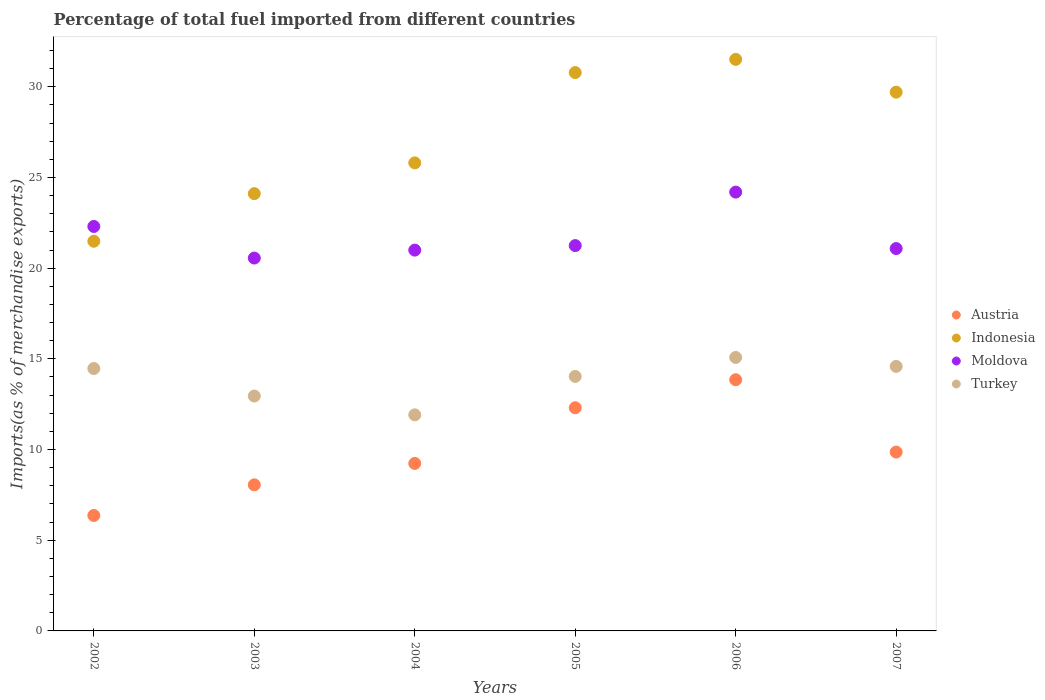How many different coloured dotlines are there?
Provide a short and direct response. 4. What is the percentage of imports to different countries in Turkey in 2006?
Ensure brevity in your answer.  15.08. Across all years, what is the maximum percentage of imports to different countries in Turkey?
Offer a very short reply. 15.08. Across all years, what is the minimum percentage of imports to different countries in Indonesia?
Ensure brevity in your answer.  21.48. In which year was the percentage of imports to different countries in Turkey maximum?
Offer a terse response. 2006. In which year was the percentage of imports to different countries in Indonesia minimum?
Your answer should be compact. 2002. What is the total percentage of imports to different countries in Moldova in the graph?
Your answer should be compact. 130.37. What is the difference between the percentage of imports to different countries in Indonesia in 2005 and that in 2006?
Provide a short and direct response. -0.73. What is the difference between the percentage of imports to different countries in Turkey in 2003 and the percentage of imports to different countries in Austria in 2005?
Offer a very short reply. 0.65. What is the average percentage of imports to different countries in Indonesia per year?
Make the answer very short. 27.23. In the year 2006, what is the difference between the percentage of imports to different countries in Turkey and percentage of imports to different countries in Indonesia?
Make the answer very short. -16.43. In how many years, is the percentage of imports to different countries in Moldova greater than 5 %?
Your answer should be compact. 6. What is the ratio of the percentage of imports to different countries in Turkey in 2002 to that in 2006?
Offer a very short reply. 0.96. Is the percentage of imports to different countries in Indonesia in 2003 less than that in 2007?
Your response must be concise. Yes. What is the difference between the highest and the second highest percentage of imports to different countries in Austria?
Keep it short and to the point. 1.55. What is the difference between the highest and the lowest percentage of imports to different countries in Austria?
Ensure brevity in your answer.  7.48. In how many years, is the percentage of imports to different countries in Moldova greater than the average percentage of imports to different countries in Moldova taken over all years?
Give a very brief answer. 2. Is the sum of the percentage of imports to different countries in Austria in 2004 and 2007 greater than the maximum percentage of imports to different countries in Turkey across all years?
Your answer should be compact. Yes. Is the percentage of imports to different countries in Austria strictly greater than the percentage of imports to different countries in Moldova over the years?
Provide a succinct answer. No. How many dotlines are there?
Make the answer very short. 4. What is the difference between two consecutive major ticks on the Y-axis?
Give a very brief answer. 5. Are the values on the major ticks of Y-axis written in scientific E-notation?
Ensure brevity in your answer.  No. Does the graph contain grids?
Offer a very short reply. No. How are the legend labels stacked?
Give a very brief answer. Vertical. What is the title of the graph?
Provide a short and direct response. Percentage of total fuel imported from different countries. Does "Trinidad and Tobago" appear as one of the legend labels in the graph?
Keep it short and to the point. No. What is the label or title of the Y-axis?
Provide a succinct answer. Imports(as % of merchandise exports). What is the Imports(as % of merchandise exports) in Austria in 2002?
Offer a very short reply. 6.37. What is the Imports(as % of merchandise exports) in Indonesia in 2002?
Your answer should be very brief. 21.48. What is the Imports(as % of merchandise exports) in Moldova in 2002?
Your answer should be compact. 22.3. What is the Imports(as % of merchandise exports) of Turkey in 2002?
Provide a short and direct response. 14.47. What is the Imports(as % of merchandise exports) of Austria in 2003?
Give a very brief answer. 8.05. What is the Imports(as % of merchandise exports) in Indonesia in 2003?
Offer a terse response. 24.11. What is the Imports(as % of merchandise exports) in Moldova in 2003?
Keep it short and to the point. 20.56. What is the Imports(as % of merchandise exports) in Turkey in 2003?
Keep it short and to the point. 12.95. What is the Imports(as % of merchandise exports) in Austria in 2004?
Provide a succinct answer. 9.24. What is the Imports(as % of merchandise exports) of Indonesia in 2004?
Your answer should be very brief. 25.8. What is the Imports(as % of merchandise exports) of Moldova in 2004?
Your answer should be very brief. 21. What is the Imports(as % of merchandise exports) of Turkey in 2004?
Give a very brief answer. 11.91. What is the Imports(as % of merchandise exports) of Austria in 2005?
Provide a succinct answer. 12.3. What is the Imports(as % of merchandise exports) in Indonesia in 2005?
Provide a short and direct response. 30.78. What is the Imports(as % of merchandise exports) of Moldova in 2005?
Offer a very short reply. 21.24. What is the Imports(as % of merchandise exports) of Turkey in 2005?
Provide a succinct answer. 14.03. What is the Imports(as % of merchandise exports) in Austria in 2006?
Your response must be concise. 13.85. What is the Imports(as % of merchandise exports) in Indonesia in 2006?
Give a very brief answer. 31.51. What is the Imports(as % of merchandise exports) in Moldova in 2006?
Make the answer very short. 24.19. What is the Imports(as % of merchandise exports) in Turkey in 2006?
Your answer should be compact. 15.08. What is the Imports(as % of merchandise exports) of Austria in 2007?
Provide a short and direct response. 9.86. What is the Imports(as % of merchandise exports) in Indonesia in 2007?
Offer a terse response. 29.7. What is the Imports(as % of merchandise exports) in Moldova in 2007?
Provide a short and direct response. 21.08. What is the Imports(as % of merchandise exports) of Turkey in 2007?
Ensure brevity in your answer.  14.58. Across all years, what is the maximum Imports(as % of merchandise exports) of Austria?
Your answer should be compact. 13.85. Across all years, what is the maximum Imports(as % of merchandise exports) in Indonesia?
Your answer should be compact. 31.51. Across all years, what is the maximum Imports(as % of merchandise exports) in Moldova?
Keep it short and to the point. 24.19. Across all years, what is the maximum Imports(as % of merchandise exports) of Turkey?
Offer a terse response. 15.08. Across all years, what is the minimum Imports(as % of merchandise exports) of Austria?
Make the answer very short. 6.37. Across all years, what is the minimum Imports(as % of merchandise exports) of Indonesia?
Give a very brief answer. 21.48. Across all years, what is the minimum Imports(as % of merchandise exports) in Moldova?
Make the answer very short. 20.56. Across all years, what is the minimum Imports(as % of merchandise exports) of Turkey?
Your response must be concise. 11.91. What is the total Imports(as % of merchandise exports) of Austria in the graph?
Offer a very short reply. 59.67. What is the total Imports(as % of merchandise exports) of Indonesia in the graph?
Your answer should be compact. 163.4. What is the total Imports(as % of merchandise exports) of Moldova in the graph?
Provide a succinct answer. 130.37. What is the total Imports(as % of merchandise exports) of Turkey in the graph?
Offer a terse response. 83.02. What is the difference between the Imports(as % of merchandise exports) of Austria in 2002 and that in 2003?
Provide a short and direct response. -1.69. What is the difference between the Imports(as % of merchandise exports) of Indonesia in 2002 and that in 2003?
Your response must be concise. -2.62. What is the difference between the Imports(as % of merchandise exports) in Moldova in 2002 and that in 2003?
Provide a succinct answer. 1.74. What is the difference between the Imports(as % of merchandise exports) of Turkey in 2002 and that in 2003?
Your answer should be very brief. 1.52. What is the difference between the Imports(as % of merchandise exports) of Austria in 2002 and that in 2004?
Your response must be concise. -2.87. What is the difference between the Imports(as % of merchandise exports) in Indonesia in 2002 and that in 2004?
Make the answer very short. -4.32. What is the difference between the Imports(as % of merchandise exports) of Moldova in 2002 and that in 2004?
Your answer should be very brief. 1.3. What is the difference between the Imports(as % of merchandise exports) of Turkey in 2002 and that in 2004?
Ensure brevity in your answer.  2.55. What is the difference between the Imports(as % of merchandise exports) in Austria in 2002 and that in 2005?
Offer a very short reply. -5.94. What is the difference between the Imports(as % of merchandise exports) of Indonesia in 2002 and that in 2005?
Your response must be concise. -9.3. What is the difference between the Imports(as % of merchandise exports) in Moldova in 2002 and that in 2005?
Give a very brief answer. 1.06. What is the difference between the Imports(as % of merchandise exports) in Turkey in 2002 and that in 2005?
Offer a terse response. 0.44. What is the difference between the Imports(as % of merchandise exports) in Austria in 2002 and that in 2006?
Ensure brevity in your answer.  -7.48. What is the difference between the Imports(as % of merchandise exports) in Indonesia in 2002 and that in 2006?
Keep it short and to the point. -10.03. What is the difference between the Imports(as % of merchandise exports) of Moldova in 2002 and that in 2006?
Your response must be concise. -1.89. What is the difference between the Imports(as % of merchandise exports) in Turkey in 2002 and that in 2006?
Keep it short and to the point. -0.61. What is the difference between the Imports(as % of merchandise exports) in Austria in 2002 and that in 2007?
Your response must be concise. -3.5. What is the difference between the Imports(as % of merchandise exports) of Indonesia in 2002 and that in 2007?
Offer a terse response. -8.22. What is the difference between the Imports(as % of merchandise exports) in Moldova in 2002 and that in 2007?
Your response must be concise. 1.22. What is the difference between the Imports(as % of merchandise exports) of Turkey in 2002 and that in 2007?
Your answer should be compact. -0.12. What is the difference between the Imports(as % of merchandise exports) in Austria in 2003 and that in 2004?
Provide a short and direct response. -1.18. What is the difference between the Imports(as % of merchandise exports) in Indonesia in 2003 and that in 2004?
Provide a short and direct response. -1.7. What is the difference between the Imports(as % of merchandise exports) in Moldova in 2003 and that in 2004?
Give a very brief answer. -0.44. What is the difference between the Imports(as % of merchandise exports) of Turkey in 2003 and that in 2004?
Make the answer very short. 1.04. What is the difference between the Imports(as % of merchandise exports) of Austria in 2003 and that in 2005?
Offer a terse response. -4.25. What is the difference between the Imports(as % of merchandise exports) of Indonesia in 2003 and that in 2005?
Offer a terse response. -6.67. What is the difference between the Imports(as % of merchandise exports) of Moldova in 2003 and that in 2005?
Provide a succinct answer. -0.69. What is the difference between the Imports(as % of merchandise exports) in Turkey in 2003 and that in 2005?
Offer a terse response. -1.08. What is the difference between the Imports(as % of merchandise exports) in Austria in 2003 and that in 2006?
Keep it short and to the point. -5.79. What is the difference between the Imports(as % of merchandise exports) of Indonesia in 2003 and that in 2006?
Give a very brief answer. -7.4. What is the difference between the Imports(as % of merchandise exports) of Moldova in 2003 and that in 2006?
Offer a terse response. -3.64. What is the difference between the Imports(as % of merchandise exports) in Turkey in 2003 and that in 2006?
Your answer should be compact. -2.13. What is the difference between the Imports(as % of merchandise exports) of Austria in 2003 and that in 2007?
Make the answer very short. -1.81. What is the difference between the Imports(as % of merchandise exports) in Indonesia in 2003 and that in 2007?
Keep it short and to the point. -5.59. What is the difference between the Imports(as % of merchandise exports) of Moldova in 2003 and that in 2007?
Offer a very short reply. -0.52. What is the difference between the Imports(as % of merchandise exports) in Turkey in 2003 and that in 2007?
Give a very brief answer. -1.63. What is the difference between the Imports(as % of merchandise exports) of Austria in 2004 and that in 2005?
Provide a succinct answer. -3.07. What is the difference between the Imports(as % of merchandise exports) in Indonesia in 2004 and that in 2005?
Your answer should be compact. -4.98. What is the difference between the Imports(as % of merchandise exports) of Moldova in 2004 and that in 2005?
Keep it short and to the point. -0.25. What is the difference between the Imports(as % of merchandise exports) in Turkey in 2004 and that in 2005?
Offer a very short reply. -2.12. What is the difference between the Imports(as % of merchandise exports) of Austria in 2004 and that in 2006?
Offer a terse response. -4.61. What is the difference between the Imports(as % of merchandise exports) of Indonesia in 2004 and that in 2006?
Your answer should be very brief. -5.71. What is the difference between the Imports(as % of merchandise exports) in Moldova in 2004 and that in 2006?
Provide a succinct answer. -3.2. What is the difference between the Imports(as % of merchandise exports) in Turkey in 2004 and that in 2006?
Ensure brevity in your answer.  -3.16. What is the difference between the Imports(as % of merchandise exports) in Austria in 2004 and that in 2007?
Your answer should be very brief. -0.63. What is the difference between the Imports(as % of merchandise exports) of Indonesia in 2004 and that in 2007?
Your answer should be very brief. -3.9. What is the difference between the Imports(as % of merchandise exports) of Moldova in 2004 and that in 2007?
Provide a short and direct response. -0.09. What is the difference between the Imports(as % of merchandise exports) of Turkey in 2004 and that in 2007?
Your answer should be compact. -2.67. What is the difference between the Imports(as % of merchandise exports) in Austria in 2005 and that in 2006?
Offer a terse response. -1.55. What is the difference between the Imports(as % of merchandise exports) of Indonesia in 2005 and that in 2006?
Offer a very short reply. -0.73. What is the difference between the Imports(as % of merchandise exports) in Moldova in 2005 and that in 2006?
Your response must be concise. -2.95. What is the difference between the Imports(as % of merchandise exports) of Turkey in 2005 and that in 2006?
Offer a terse response. -1.05. What is the difference between the Imports(as % of merchandise exports) in Austria in 2005 and that in 2007?
Keep it short and to the point. 2.44. What is the difference between the Imports(as % of merchandise exports) of Indonesia in 2005 and that in 2007?
Give a very brief answer. 1.08. What is the difference between the Imports(as % of merchandise exports) of Moldova in 2005 and that in 2007?
Your answer should be compact. 0.16. What is the difference between the Imports(as % of merchandise exports) of Turkey in 2005 and that in 2007?
Make the answer very short. -0.55. What is the difference between the Imports(as % of merchandise exports) in Austria in 2006 and that in 2007?
Offer a very short reply. 3.99. What is the difference between the Imports(as % of merchandise exports) of Indonesia in 2006 and that in 2007?
Offer a very short reply. 1.81. What is the difference between the Imports(as % of merchandise exports) of Moldova in 2006 and that in 2007?
Ensure brevity in your answer.  3.11. What is the difference between the Imports(as % of merchandise exports) in Turkey in 2006 and that in 2007?
Make the answer very short. 0.49. What is the difference between the Imports(as % of merchandise exports) of Austria in 2002 and the Imports(as % of merchandise exports) of Indonesia in 2003?
Make the answer very short. -17.74. What is the difference between the Imports(as % of merchandise exports) in Austria in 2002 and the Imports(as % of merchandise exports) in Moldova in 2003?
Your answer should be compact. -14.19. What is the difference between the Imports(as % of merchandise exports) of Austria in 2002 and the Imports(as % of merchandise exports) of Turkey in 2003?
Give a very brief answer. -6.59. What is the difference between the Imports(as % of merchandise exports) of Indonesia in 2002 and the Imports(as % of merchandise exports) of Moldova in 2003?
Provide a short and direct response. 0.93. What is the difference between the Imports(as % of merchandise exports) in Indonesia in 2002 and the Imports(as % of merchandise exports) in Turkey in 2003?
Your response must be concise. 8.53. What is the difference between the Imports(as % of merchandise exports) of Moldova in 2002 and the Imports(as % of merchandise exports) of Turkey in 2003?
Your response must be concise. 9.35. What is the difference between the Imports(as % of merchandise exports) of Austria in 2002 and the Imports(as % of merchandise exports) of Indonesia in 2004?
Provide a succinct answer. -19.44. What is the difference between the Imports(as % of merchandise exports) of Austria in 2002 and the Imports(as % of merchandise exports) of Moldova in 2004?
Make the answer very short. -14.63. What is the difference between the Imports(as % of merchandise exports) in Austria in 2002 and the Imports(as % of merchandise exports) in Turkey in 2004?
Offer a terse response. -5.55. What is the difference between the Imports(as % of merchandise exports) of Indonesia in 2002 and the Imports(as % of merchandise exports) of Moldova in 2004?
Offer a terse response. 0.49. What is the difference between the Imports(as % of merchandise exports) of Indonesia in 2002 and the Imports(as % of merchandise exports) of Turkey in 2004?
Your answer should be compact. 9.57. What is the difference between the Imports(as % of merchandise exports) of Moldova in 2002 and the Imports(as % of merchandise exports) of Turkey in 2004?
Provide a succinct answer. 10.39. What is the difference between the Imports(as % of merchandise exports) of Austria in 2002 and the Imports(as % of merchandise exports) of Indonesia in 2005?
Offer a terse response. -24.42. What is the difference between the Imports(as % of merchandise exports) of Austria in 2002 and the Imports(as % of merchandise exports) of Moldova in 2005?
Provide a succinct answer. -14.88. What is the difference between the Imports(as % of merchandise exports) of Austria in 2002 and the Imports(as % of merchandise exports) of Turkey in 2005?
Your response must be concise. -7.67. What is the difference between the Imports(as % of merchandise exports) of Indonesia in 2002 and the Imports(as % of merchandise exports) of Moldova in 2005?
Your answer should be compact. 0.24. What is the difference between the Imports(as % of merchandise exports) in Indonesia in 2002 and the Imports(as % of merchandise exports) in Turkey in 2005?
Your response must be concise. 7.45. What is the difference between the Imports(as % of merchandise exports) of Moldova in 2002 and the Imports(as % of merchandise exports) of Turkey in 2005?
Give a very brief answer. 8.27. What is the difference between the Imports(as % of merchandise exports) in Austria in 2002 and the Imports(as % of merchandise exports) in Indonesia in 2006?
Provide a succinct answer. -25.15. What is the difference between the Imports(as % of merchandise exports) of Austria in 2002 and the Imports(as % of merchandise exports) of Moldova in 2006?
Your answer should be very brief. -17.83. What is the difference between the Imports(as % of merchandise exports) in Austria in 2002 and the Imports(as % of merchandise exports) in Turkey in 2006?
Provide a short and direct response. -8.71. What is the difference between the Imports(as % of merchandise exports) in Indonesia in 2002 and the Imports(as % of merchandise exports) in Moldova in 2006?
Your response must be concise. -2.71. What is the difference between the Imports(as % of merchandise exports) in Indonesia in 2002 and the Imports(as % of merchandise exports) in Turkey in 2006?
Your response must be concise. 6.41. What is the difference between the Imports(as % of merchandise exports) in Moldova in 2002 and the Imports(as % of merchandise exports) in Turkey in 2006?
Provide a succinct answer. 7.22. What is the difference between the Imports(as % of merchandise exports) of Austria in 2002 and the Imports(as % of merchandise exports) of Indonesia in 2007?
Ensure brevity in your answer.  -23.34. What is the difference between the Imports(as % of merchandise exports) in Austria in 2002 and the Imports(as % of merchandise exports) in Moldova in 2007?
Your answer should be compact. -14.72. What is the difference between the Imports(as % of merchandise exports) of Austria in 2002 and the Imports(as % of merchandise exports) of Turkey in 2007?
Offer a terse response. -8.22. What is the difference between the Imports(as % of merchandise exports) of Indonesia in 2002 and the Imports(as % of merchandise exports) of Moldova in 2007?
Give a very brief answer. 0.4. What is the difference between the Imports(as % of merchandise exports) in Indonesia in 2002 and the Imports(as % of merchandise exports) in Turkey in 2007?
Offer a very short reply. 6.9. What is the difference between the Imports(as % of merchandise exports) in Moldova in 2002 and the Imports(as % of merchandise exports) in Turkey in 2007?
Your response must be concise. 7.72. What is the difference between the Imports(as % of merchandise exports) of Austria in 2003 and the Imports(as % of merchandise exports) of Indonesia in 2004?
Provide a short and direct response. -17.75. What is the difference between the Imports(as % of merchandise exports) in Austria in 2003 and the Imports(as % of merchandise exports) in Moldova in 2004?
Make the answer very short. -12.94. What is the difference between the Imports(as % of merchandise exports) of Austria in 2003 and the Imports(as % of merchandise exports) of Turkey in 2004?
Provide a short and direct response. -3.86. What is the difference between the Imports(as % of merchandise exports) of Indonesia in 2003 and the Imports(as % of merchandise exports) of Moldova in 2004?
Your answer should be very brief. 3.11. What is the difference between the Imports(as % of merchandise exports) of Indonesia in 2003 and the Imports(as % of merchandise exports) of Turkey in 2004?
Provide a succinct answer. 12.2. What is the difference between the Imports(as % of merchandise exports) of Moldova in 2003 and the Imports(as % of merchandise exports) of Turkey in 2004?
Make the answer very short. 8.64. What is the difference between the Imports(as % of merchandise exports) of Austria in 2003 and the Imports(as % of merchandise exports) of Indonesia in 2005?
Your answer should be compact. -22.73. What is the difference between the Imports(as % of merchandise exports) in Austria in 2003 and the Imports(as % of merchandise exports) in Moldova in 2005?
Offer a very short reply. -13.19. What is the difference between the Imports(as % of merchandise exports) of Austria in 2003 and the Imports(as % of merchandise exports) of Turkey in 2005?
Offer a terse response. -5.98. What is the difference between the Imports(as % of merchandise exports) in Indonesia in 2003 and the Imports(as % of merchandise exports) in Moldova in 2005?
Ensure brevity in your answer.  2.86. What is the difference between the Imports(as % of merchandise exports) of Indonesia in 2003 and the Imports(as % of merchandise exports) of Turkey in 2005?
Give a very brief answer. 10.08. What is the difference between the Imports(as % of merchandise exports) of Moldova in 2003 and the Imports(as % of merchandise exports) of Turkey in 2005?
Keep it short and to the point. 6.53. What is the difference between the Imports(as % of merchandise exports) of Austria in 2003 and the Imports(as % of merchandise exports) of Indonesia in 2006?
Your response must be concise. -23.46. What is the difference between the Imports(as % of merchandise exports) of Austria in 2003 and the Imports(as % of merchandise exports) of Moldova in 2006?
Offer a very short reply. -16.14. What is the difference between the Imports(as % of merchandise exports) of Austria in 2003 and the Imports(as % of merchandise exports) of Turkey in 2006?
Offer a very short reply. -7.02. What is the difference between the Imports(as % of merchandise exports) in Indonesia in 2003 and the Imports(as % of merchandise exports) in Moldova in 2006?
Give a very brief answer. -0.08. What is the difference between the Imports(as % of merchandise exports) in Indonesia in 2003 and the Imports(as % of merchandise exports) in Turkey in 2006?
Your answer should be very brief. 9.03. What is the difference between the Imports(as % of merchandise exports) in Moldova in 2003 and the Imports(as % of merchandise exports) in Turkey in 2006?
Ensure brevity in your answer.  5.48. What is the difference between the Imports(as % of merchandise exports) of Austria in 2003 and the Imports(as % of merchandise exports) of Indonesia in 2007?
Give a very brief answer. -21.65. What is the difference between the Imports(as % of merchandise exports) of Austria in 2003 and the Imports(as % of merchandise exports) of Moldova in 2007?
Ensure brevity in your answer.  -13.03. What is the difference between the Imports(as % of merchandise exports) in Austria in 2003 and the Imports(as % of merchandise exports) in Turkey in 2007?
Ensure brevity in your answer.  -6.53. What is the difference between the Imports(as % of merchandise exports) of Indonesia in 2003 and the Imports(as % of merchandise exports) of Moldova in 2007?
Your response must be concise. 3.03. What is the difference between the Imports(as % of merchandise exports) of Indonesia in 2003 and the Imports(as % of merchandise exports) of Turkey in 2007?
Provide a short and direct response. 9.53. What is the difference between the Imports(as % of merchandise exports) of Moldova in 2003 and the Imports(as % of merchandise exports) of Turkey in 2007?
Make the answer very short. 5.97. What is the difference between the Imports(as % of merchandise exports) of Austria in 2004 and the Imports(as % of merchandise exports) of Indonesia in 2005?
Ensure brevity in your answer.  -21.55. What is the difference between the Imports(as % of merchandise exports) in Austria in 2004 and the Imports(as % of merchandise exports) in Moldova in 2005?
Provide a short and direct response. -12.01. What is the difference between the Imports(as % of merchandise exports) of Austria in 2004 and the Imports(as % of merchandise exports) of Turkey in 2005?
Keep it short and to the point. -4.8. What is the difference between the Imports(as % of merchandise exports) of Indonesia in 2004 and the Imports(as % of merchandise exports) of Moldova in 2005?
Provide a succinct answer. 4.56. What is the difference between the Imports(as % of merchandise exports) of Indonesia in 2004 and the Imports(as % of merchandise exports) of Turkey in 2005?
Provide a short and direct response. 11.77. What is the difference between the Imports(as % of merchandise exports) in Moldova in 2004 and the Imports(as % of merchandise exports) in Turkey in 2005?
Provide a short and direct response. 6.96. What is the difference between the Imports(as % of merchandise exports) in Austria in 2004 and the Imports(as % of merchandise exports) in Indonesia in 2006?
Provide a short and direct response. -22.28. What is the difference between the Imports(as % of merchandise exports) of Austria in 2004 and the Imports(as % of merchandise exports) of Moldova in 2006?
Offer a very short reply. -14.96. What is the difference between the Imports(as % of merchandise exports) of Austria in 2004 and the Imports(as % of merchandise exports) of Turkey in 2006?
Make the answer very short. -5.84. What is the difference between the Imports(as % of merchandise exports) in Indonesia in 2004 and the Imports(as % of merchandise exports) in Moldova in 2006?
Offer a very short reply. 1.61. What is the difference between the Imports(as % of merchandise exports) of Indonesia in 2004 and the Imports(as % of merchandise exports) of Turkey in 2006?
Your answer should be compact. 10.73. What is the difference between the Imports(as % of merchandise exports) in Moldova in 2004 and the Imports(as % of merchandise exports) in Turkey in 2006?
Offer a very short reply. 5.92. What is the difference between the Imports(as % of merchandise exports) of Austria in 2004 and the Imports(as % of merchandise exports) of Indonesia in 2007?
Give a very brief answer. -20.47. What is the difference between the Imports(as % of merchandise exports) of Austria in 2004 and the Imports(as % of merchandise exports) of Moldova in 2007?
Give a very brief answer. -11.85. What is the difference between the Imports(as % of merchandise exports) of Austria in 2004 and the Imports(as % of merchandise exports) of Turkey in 2007?
Offer a terse response. -5.35. What is the difference between the Imports(as % of merchandise exports) of Indonesia in 2004 and the Imports(as % of merchandise exports) of Moldova in 2007?
Ensure brevity in your answer.  4.72. What is the difference between the Imports(as % of merchandise exports) in Indonesia in 2004 and the Imports(as % of merchandise exports) in Turkey in 2007?
Offer a terse response. 11.22. What is the difference between the Imports(as % of merchandise exports) in Moldova in 2004 and the Imports(as % of merchandise exports) in Turkey in 2007?
Ensure brevity in your answer.  6.41. What is the difference between the Imports(as % of merchandise exports) in Austria in 2005 and the Imports(as % of merchandise exports) in Indonesia in 2006?
Your answer should be compact. -19.21. What is the difference between the Imports(as % of merchandise exports) in Austria in 2005 and the Imports(as % of merchandise exports) in Moldova in 2006?
Your answer should be very brief. -11.89. What is the difference between the Imports(as % of merchandise exports) of Austria in 2005 and the Imports(as % of merchandise exports) of Turkey in 2006?
Your answer should be compact. -2.77. What is the difference between the Imports(as % of merchandise exports) in Indonesia in 2005 and the Imports(as % of merchandise exports) in Moldova in 2006?
Make the answer very short. 6.59. What is the difference between the Imports(as % of merchandise exports) of Indonesia in 2005 and the Imports(as % of merchandise exports) of Turkey in 2006?
Your response must be concise. 15.71. What is the difference between the Imports(as % of merchandise exports) in Moldova in 2005 and the Imports(as % of merchandise exports) in Turkey in 2006?
Your answer should be very brief. 6.17. What is the difference between the Imports(as % of merchandise exports) of Austria in 2005 and the Imports(as % of merchandise exports) of Indonesia in 2007?
Your answer should be very brief. -17.4. What is the difference between the Imports(as % of merchandise exports) of Austria in 2005 and the Imports(as % of merchandise exports) of Moldova in 2007?
Your response must be concise. -8.78. What is the difference between the Imports(as % of merchandise exports) in Austria in 2005 and the Imports(as % of merchandise exports) in Turkey in 2007?
Offer a terse response. -2.28. What is the difference between the Imports(as % of merchandise exports) of Indonesia in 2005 and the Imports(as % of merchandise exports) of Moldova in 2007?
Your answer should be compact. 9.7. What is the difference between the Imports(as % of merchandise exports) in Indonesia in 2005 and the Imports(as % of merchandise exports) in Turkey in 2007?
Ensure brevity in your answer.  16.2. What is the difference between the Imports(as % of merchandise exports) of Moldova in 2005 and the Imports(as % of merchandise exports) of Turkey in 2007?
Offer a terse response. 6.66. What is the difference between the Imports(as % of merchandise exports) of Austria in 2006 and the Imports(as % of merchandise exports) of Indonesia in 2007?
Offer a terse response. -15.86. What is the difference between the Imports(as % of merchandise exports) in Austria in 2006 and the Imports(as % of merchandise exports) in Moldova in 2007?
Give a very brief answer. -7.23. What is the difference between the Imports(as % of merchandise exports) of Austria in 2006 and the Imports(as % of merchandise exports) of Turkey in 2007?
Ensure brevity in your answer.  -0.74. What is the difference between the Imports(as % of merchandise exports) in Indonesia in 2006 and the Imports(as % of merchandise exports) in Moldova in 2007?
Your answer should be compact. 10.43. What is the difference between the Imports(as % of merchandise exports) of Indonesia in 2006 and the Imports(as % of merchandise exports) of Turkey in 2007?
Offer a terse response. 16.93. What is the difference between the Imports(as % of merchandise exports) in Moldova in 2006 and the Imports(as % of merchandise exports) in Turkey in 2007?
Your answer should be compact. 9.61. What is the average Imports(as % of merchandise exports) of Austria per year?
Your response must be concise. 9.94. What is the average Imports(as % of merchandise exports) of Indonesia per year?
Your response must be concise. 27.23. What is the average Imports(as % of merchandise exports) of Moldova per year?
Your answer should be very brief. 21.73. What is the average Imports(as % of merchandise exports) in Turkey per year?
Make the answer very short. 13.84. In the year 2002, what is the difference between the Imports(as % of merchandise exports) in Austria and Imports(as % of merchandise exports) in Indonesia?
Your answer should be compact. -15.12. In the year 2002, what is the difference between the Imports(as % of merchandise exports) in Austria and Imports(as % of merchandise exports) in Moldova?
Your answer should be very brief. -15.94. In the year 2002, what is the difference between the Imports(as % of merchandise exports) in Austria and Imports(as % of merchandise exports) in Turkey?
Give a very brief answer. -8.1. In the year 2002, what is the difference between the Imports(as % of merchandise exports) of Indonesia and Imports(as % of merchandise exports) of Moldova?
Offer a terse response. -0.82. In the year 2002, what is the difference between the Imports(as % of merchandise exports) in Indonesia and Imports(as % of merchandise exports) in Turkey?
Make the answer very short. 7.02. In the year 2002, what is the difference between the Imports(as % of merchandise exports) in Moldova and Imports(as % of merchandise exports) in Turkey?
Make the answer very short. 7.83. In the year 2003, what is the difference between the Imports(as % of merchandise exports) in Austria and Imports(as % of merchandise exports) in Indonesia?
Provide a succinct answer. -16.05. In the year 2003, what is the difference between the Imports(as % of merchandise exports) of Austria and Imports(as % of merchandise exports) of Moldova?
Make the answer very short. -12.5. In the year 2003, what is the difference between the Imports(as % of merchandise exports) in Austria and Imports(as % of merchandise exports) in Turkey?
Your answer should be compact. -4.9. In the year 2003, what is the difference between the Imports(as % of merchandise exports) in Indonesia and Imports(as % of merchandise exports) in Moldova?
Give a very brief answer. 3.55. In the year 2003, what is the difference between the Imports(as % of merchandise exports) in Indonesia and Imports(as % of merchandise exports) in Turkey?
Make the answer very short. 11.16. In the year 2003, what is the difference between the Imports(as % of merchandise exports) of Moldova and Imports(as % of merchandise exports) of Turkey?
Your answer should be very brief. 7.61. In the year 2004, what is the difference between the Imports(as % of merchandise exports) of Austria and Imports(as % of merchandise exports) of Indonesia?
Your answer should be compact. -16.57. In the year 2004, what is the difference between the Imports(as % of merchandise exports) in Austria and Imports(as % of merchandise exports) in Moldova?
Give a very brief answer. -11.76. In the year 2004, what is the difference between the Imports(as % of merchandise exports) of Austria and Imports(as % of merchandise exports) of Turkey?
Ensure brevity in your answer.  -2.68. In the year 2004, what is the difference between the Imports(as % of merchandise exports) of Indonesia and Imports(as % of merchandise exports) of Moldova?
Make the answer very short. 4.81. In the year 2004, what is the difference between the Imports(as % of merchandise exports) in Indonesia and Imports(as % of merchandise exports) in Turkey?
Your answer should be compact. 13.89. In the year 2004, what is the difference between the Imports(as % of merchandise exports) in Moldova and Imports(as % of merchandise exports) in Turkey?
Offer a terse response. 9.08. In the year 2005, what is the difference between the Imports(as % of merchandise exports) in Austria and Imports(as % of merchandise exports) in Indonesia?
Provide a succinct answer. -18.48. In the year 2005, what is the difference between the Imports(as % of merchandise exports) in Austria and Imports(as % of merchandise exports) in Moldova?
Ensure brevity in your answer.  -8.94. In the year 2005, what is the difference between the Imports(as % of merchandise exports) in Austria and Imports(as % of merchandise exports) in Turkey?
Ensure brevity in your answer.  -1.73. In the year 2005, what is the difference between the Imports(as % of merchandise exports) of Indonesia and Imports(as % of merchandise exports) of Moldova?
Your response must be concise. 9.54. In the year 2005, what is the difference between the Imports(as % of merchandise exports) of Indonesia and Imports(as % of merchandise exports) of Turkey?
Offer a terse response. 16.75. In the year 2005, what is the difference between the Imports(as % of merchandise exports) of Moldova and Imports(as % of merchandise exports) of Turkey?
Your answer should be compact. 7.21. In the year 2006, what is the difference between the Imports(as % of merchandise exports) in Austria and Imports(as % of merchandise exports) in Indonesia?
Make the answer very short. -17.66. In the year 2006, what is the difference between the Imports(as % of merchandise exports) in Austria and Imports(as % of merchandise exports) in Moldova?
Provide a succinct answer. -10.35. In the year 2006, what is the difference between the Imports(as % of merchandise exports) in Austria and Imports(as % of merchandise exports) in Turkey?
Offer a very short reply. -1.23. In the year 2006, what is the difference between the Imports(as % of merchandise exports) of Indonesia and Imports(as % of merchandise exports) of Moldova?
Ensure brevity in your answer.  7.32. In the year 2006, what is the difference between the Imports(as % of merchandise exports) in Indonesia and Imports(as % of merchandise exports) in Turkey?
Keep it short and to the point. 16.43. In the year 2006, what is the difference between the Imports(as % of merchandise exports) of Moldova and Imports(as % of merchandise exports) of Turkey?
Your answer should be very brief. 9.12. In the year 2007, what is the difference between the Imports(as % of merchandise exports) of Austria and Imports(as % of merchandise exports) of Indonesia?
Make the answer very short. -19.84. In the year 2007, what is the difference between the Imports(as % of merchandise exports) in Austria and Imports(as % of merchandise exports) in Moldova?
Your answer should be very brief. -11.22. In the year 2007, what is the difference between the Imports(as % of merchandise exports) of Austria and Imports(as % of merchandise exports) of Turkey?
Your answer should be very brief. -4.72. In the year 2007, what is the difference between the Imports(as % of merchandise exports) of Indonesia and Imports(as % of merchandise exports) of Moldova?
Your answer should be very brief. 8.62. In the year 2007, what is the difference between the Imports(as % of merchandise exports) of Indonesia and Imports(as % of merchandise exports) of Turkey?
Make the answer very short. 15.12. In the year 2007, what is the difference between the Imports(as % of merchandise exports) of Moldova and Imports(as % of merchandise exports) of Turkey?
Provide a succinct answer. 6.5. What is the ratio of the Imports(as % of merchandise exports) of Austria in 2002 to that in 2003?
Your answer should be compact. 0.79. What is the ratio of the Imports(as % of merchandise exports) in Indonesia in 2002 to that in 2003?
Provide a short and direct response. 0.89. What is the ratio of the Imports(as % of merchandise exports) of Moldova in 2002 to that in 2003?
Make the answer very short. 1.08. What is the ratio of the Imports(as % of merchandise exports) in Turkey in 2002 to that in 2003?
Provide a succinct answer. 1.12. What is the ratio of the Imports(as % of merchandise exports) in Austria in 2002 to that in 2004?
Your answer should be compact. 0.69. What is the ratio of the Imports(as % of merchandise exports) of Indonesia in 2002 to that in 2004?
Keep it short and to the point. 0.83. What is the ratio of the Imports(as % of merchandise exports) of Moldova in 2002 to that in 2004?
Your answer should be very brief. 1.06. What is the ratio of the Imports(as % of merchandise exports) of Turkey in 2002 to that in 2004?
Your response must be concise. 1.21. What is the ratio of the Imports(as % of merchandise exports) in Austria in 2002 to that in 2005?
Give a very brief answer. 0.52. What is the ratio of the Imports(as % of merchandise exports) in Indonesia in 2002 to that in 2005?
Your answer should be compact. 0.7. What is the ratio of the Imports(as % of merchandise exports) in Moldova in 2002 to that in 2005?
Provide a short and direct response. 1.05. What is the ratio of the Imports(as % of merchandise exports) in Turkey in 2002 to that in 2005?
Your answer should be compact. 1.03. What is the ratio of the Imports(as % of merchandise exports) in Austria in 2002 to that in 2006?
Your answer should be very brief. 0.46. What is the ratio of the Imports(as % of merchandise exports) in Indonesia in 2002 to that in 2006?
Make the answer very short. 0.68. What is the ratio of the Imports(as % of merchandise exports) in Moldova in 2002 to that in 2006?
Offer a very short reply. 0.92. What is the ratio of the Imports(as % of merchandise exports) of Turkey in 2002 to that in 2006?
Your answer should be compact. 0.96. What is the ratio of the Imports(as % of merchandise exports) in Austria in 2002 to that in 2007?
Keep it short and to the point. 0.65. What is the ratio of the Imports(as % of merchandise exports) of Indonesia in 2002 to that in 2007?
Provide a short and direct response. 0.72. What is the ratio of the Imports(as % of merchandise exports) of Moldova in 2002 to that in 2007?
Your answer should be very brief. 1.06. What is the ratio of the Imports(as % of merchandise exports) of Turkey in 2002 to that in 2007?
Offer a very short reply. 0.99. What is the ratio of the Imports(as % of merchandise exports) of Austria in 2003 to that in 2004?
Provide a short and direct response. 0.87. What is the ratio of the Imports(as % of merchandise exports) of Indonesia in 2003 to that in 2004?
Make the answer very short. 0.93. What is the ratio of the Imports(as % of merchandise exports) of Moldova in 2003 to that in 2004?
Ensure brevity in your answer.  0.98. What is the ratio of the Imports(as % of merchandise exports) in Turkey in 2003 to that in 2004?
Keep it short and to the point. 1.09. What is the ratio of the Imports(as % of merchandise exports) in Austria in 2003 to that in 2005?
Your answer should be compact. 0.65. What is the ratio of the Imports(as % of merchandise exports) of Indonesia in 2003 to that in 2005?
Keep it short and to the point. 0.78. What is the ratio of the Imports(as % of merchandise exports) in Turkey in 2003 to that in 2005?
Ensure brevity in your answer.  0.92. What is the ratio of the Imports(as % of merchandise exports) of Austria in 2003 to that in 2006?
Give a very brief answer. 0.58. What is the ratio of the Imports(as % of merchandise exports) of Indonesia in 2003 to that in 2006?
Your answer should be compact. 0.77. What is the ratio of the Imports(as % of merchandise exports) of Moldova in 2003 to that in 2006?
Your answer should be very brief. 0.85. What is the ratio of the Imports(as % of merchandise exports) in Turkey in 2003 to that in 2006?
Offer a very short reply. 0.86. What is the ratio of the Imports(as % of merchandise exports) of Austria in 2003 to that in 2007?
Your answer should be compact. 0.82. What is the ratio of the Imports(as % of merchandise exports) of Indonesia in 2003 to that in 2007?
Ensure brevity in your answer.  0.81. What is the ratio of the Imports(as % of merchandise exports) in Moldova in 2003 to that in 2007?
Give a very brief answer. 0.98. What is the ratio of the Imports(as % of merchandise exports) in Turkey in 2003 to that in 2007?
Provide a succinct answer. 0.89. What is the ratio of the Imports(as % of merchandise exports) of Austria in 2004 to that in 2005?
Make the answer very short. 0.75. What is the ratio of the Imports(as % of merchandise exports) in Indonesia in 2004 to that in 2005?
Your answer should be compact. 0.84. What is the ratio of the Imports(as % of merchandise exports) in Moldova in 2004 to that in 2005?
Give a very brief answer. 0.99. What is the ratio of the Imports(as % of merchandise exports) of Turkey in 2004 to that in 2005?
Offer a very short reply. 0.85. What is the ratio of the Imports(as % of merchandise exports) of Austria in 2004 to that in 2006?
Provide a succinct answer. 0.67. What is the ratio of the Imports(as % of merchandise exports) in Indonesia in 2004 to that in 2006?
Make the answer very short. 0.82. What is the ratio of the Imports(as % of merchandise exports) of Moldova in 2004 to that in 2006?
Your response must be concise. 0.87. What is the ratio of the Imports(as % of merchandise exports) in Turkey in 2004 to that in 2006?
Make the answer very short. 0.79. What is the ratio of the Imports(as % of merchandise exports) of Austria in 2004 to that in 2007?
Your response must be concise. 0.94. What is the ratio of the Imports(as % of merchandise exports) in Indonesia in 2004 to that in 2007?
Keep it short and to the point. 0.87. What is the ratio of the Imports(as % of merchandise exports) of Moldova in 2004 to that in 2007?
Offer a very short reply. 1. What is the ratio of the Imports(as % of merchandise exports) of Turkey in 2004 to that in 2007?
Your answer should be compact. 0.82. What is the ratio of the Imports(as % of merchandise exports) in Austria in 2005 to that in 2006?
Ensure brevity in your answer.  0.89. What is the ratio of the Imports(as % of merchandise exports) of Indonesia in 2005 to that in 2006?
Provide a succinct answer. 0.98. What is the ratio of the Imports(as % of merchandise exports) of Moldova in 2005 to that in 2006?
Provide a short and direct response. 0.88. What is the ratio of the Imports(as % of merchandise exports) of Turkey in 2005 to that in 2006?
Keep it short and to the point. 0.93. What is the ratio of the Imports(as % of merchandise exports) in Austria in 2005 to that in 2007?
Your answer should be very brief. 1.25. What is the ratio of the Imports(as % of merchandise exports) in Indonesia in 2005 to that in 2007?
Keep it short and to the point. 1.04. What is the ratio of the Imports(as % of merchandise exports) in Moldova in 2005 to that in 2007?
Ensure brevity in your answer.  1.01. What is the ratio of the Imports(as % of merchandise exports) of Turkey in 2005 to that in 2007?
Provide a succinct answer. 0.96. What is the ratio of the Imports(as % of merchandise exports) of Austria in 2006 to that in 2007?
Your response must be concise. 1.4. What is the ratio of the Imports(as % of merchandise exports) in Indonesia in 2006 to that in 2007?
Your answer should be compact. 1.06. What is the ratio of the Imports(as % of merchandise exports) of Moldova in 2006 to that in 2007?
Make the answer very short. 1.15. What is the ratio of the Imports(as % of merchandise exports) in Turkey in 2006 to that in 2007?
Your response must be concise. 1.03. What is the difference between the highest and the second highest Imports(as % of merchandise exports) of Austria?
Offer a terse response. 1.55. What is the difference between the highest and the second highest Imports(as % of merchandise exports) in Indonesia?
Offer a very short reply. 0.73. What is the difference between the highest and the second highest Imports(as % of merchandise exports) of Moldova?
Provide a short and direct response. 1.89. What is the difference between the highest and the second highest Imports(as % of merchandise exports) in Turkey?
Give a very brief answer. 0.49. What is the difference between the highest and the lowest Imports(as % of merchandise exports) in Austria?
Give a very brief answer. 7.48. What is the difference between the highest and the lowest Imports(as % of merchandise exports) of Indonesia?
Offer a very short reply. 10.03. What is the difference between the highest and the lowest Imports(as % of merchandise exports) in Moldova?
Your answer should be very brief. 3.64. What is the difference between the highest and the lowest Imports(as % of merchandise exports) in Turkey?
Make the answer very short. 3.16. 